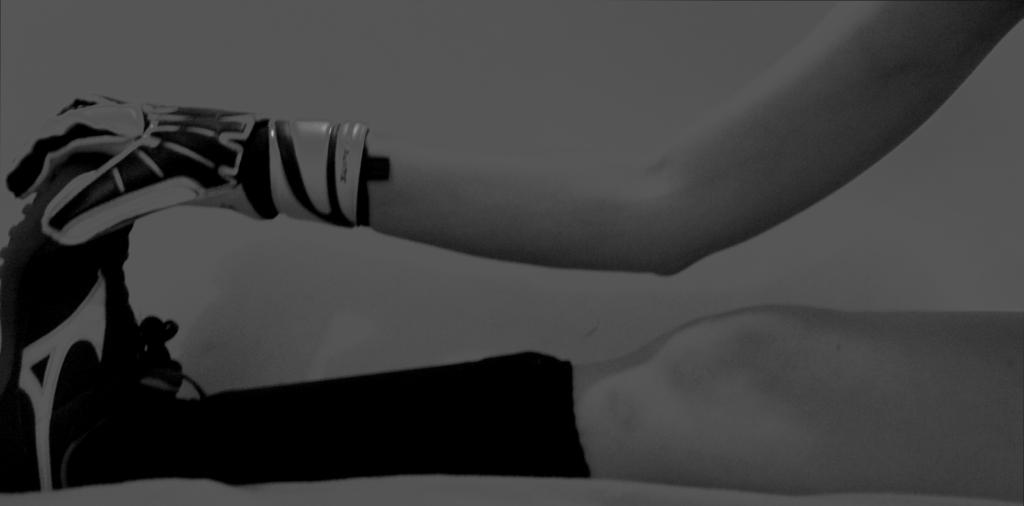What body parts of a person can be seen in the image? There is a person's leg and hand in the image. What is the person holding in the image? The person is holding a shoe in the image. What type of clothing is the person wearing on their hand? The person is wearing a glove in the image. What type of rice can be seen in the image? There is no rice present in the image. Can you describe the bee that is buzzing around the person's hand? There is no bee present in the image. 